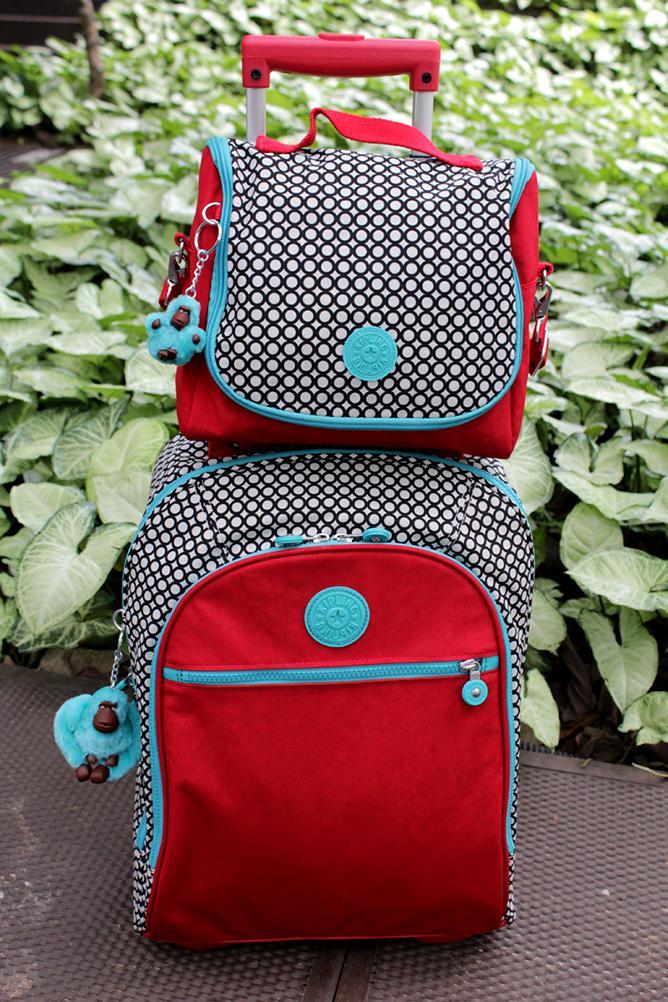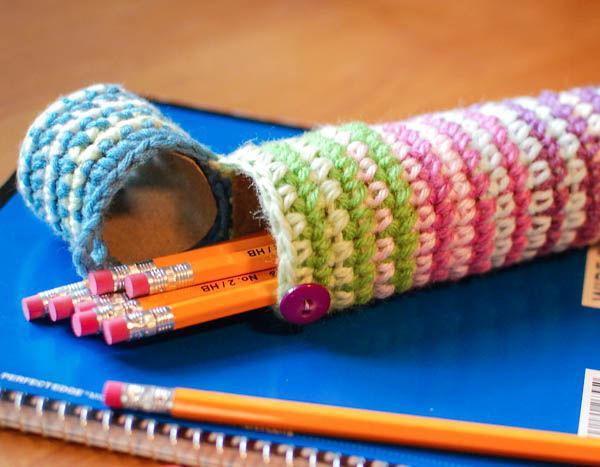The first image is the image on the left, the second image is the image on the right. Assess this claim about the two images: "A blue pencil case is holding several pencils.". Correct or not? Answer yes or no. No. 